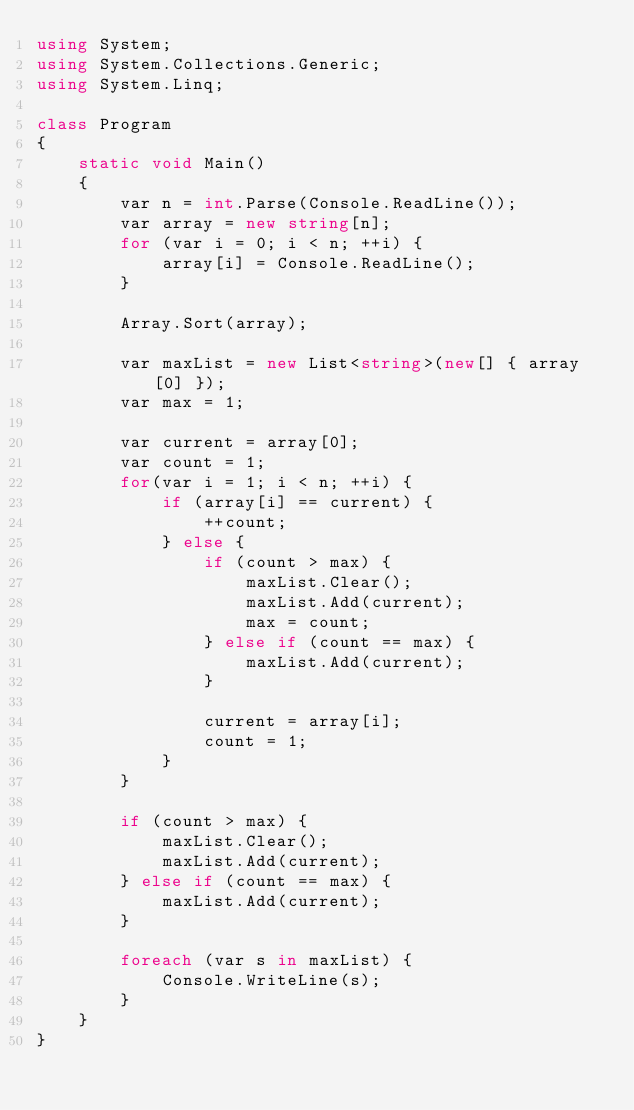Convert code to text. <code><loc_0><loc_0><loc_500><loc_500><_C#_>using System;
using System.Collections.Generic;
using System.Linq;

class Program
{
	static void Main()
	{
		var n = int.Parse(Console.ReadLine());
		var array = new string[n];
		for (var i = 0; i < n; ++i) {
			array[i] = Console.ReadLine();
		}

		Array.Sort(array);

		var maxList = new List<string>(new[] { array[0] });
		var max = 1;

		var current = array[0];
		var count = 1;
		for(var i = 1; i < n; ++i) {
			if (array[i] == current) {
				++count;
			} else {
				if (count > max) {
					maxList.Clear();
					maxList.Add(current);
					max = count;
				} else if (count == max) {
					maxList.Add(current);
				}

				current = array[i];
				count = 1;
			}
		}

		if (count > max) {
			maxList.Clear();
			maxList.Add(current);
		} else if (count == max) {
			maxList.Add(current);
		}

		foreach (var s in maxList) {
			Console.WriteLine(s);
		}
	}
}
</code> 